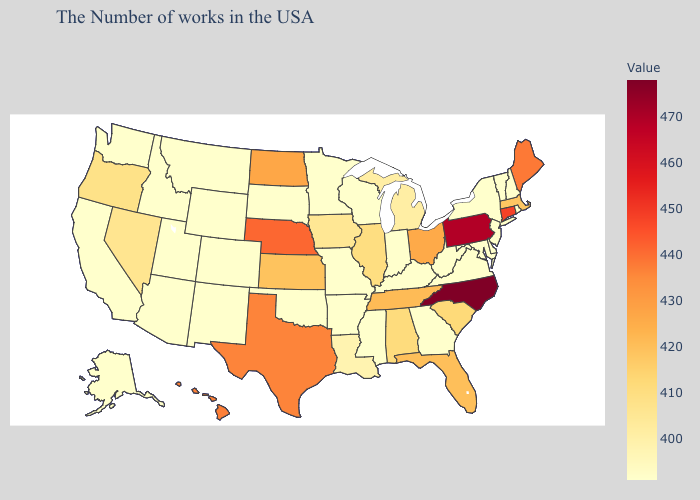Among the states that border West Virginia , does Pennsylvania have the lowest value?
Keep it brief. No. Does Hawaii have the lowest value in the West?
Answer briefly. No. Is the legend a continuous bar?
Concise answer only. Yes. Among the states that border Texas , does New Mexico have the highest value?
Be succinct. No. 